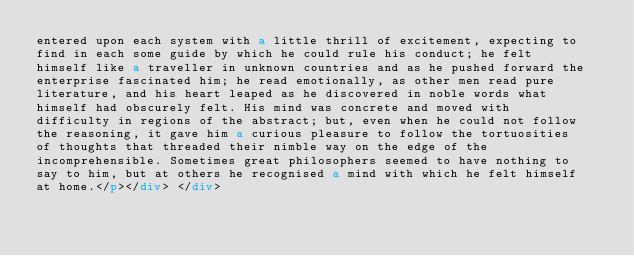<code> <loc_0><loc_0><loc_500><loc_500><_HTML_>entered upon each system with a little thrill of excitement, expecting to
find in each some guide by which he could rule his conduct; he felt
himself like a traveller in unknown countries and as he pushed forward the
enterprise fascinated him; he read emotionally, as other men read pure
literature, and his heart leaped as he discovered in noble words what
himself had obscurely felt. His mind was concrete and moved with
difficulty in regions of the abstract; but, even when he could not follow
the reasoning, it gave him a curious pleasure to follow the tortuosities
of thoughts that threaded their nimble way on the edge of the
incomprehensible. Sometimes great philosophers seemed to have nothing to
say to him, but at others he recognised a mind with which he felt himself
at home.</p></div> </div></code> 